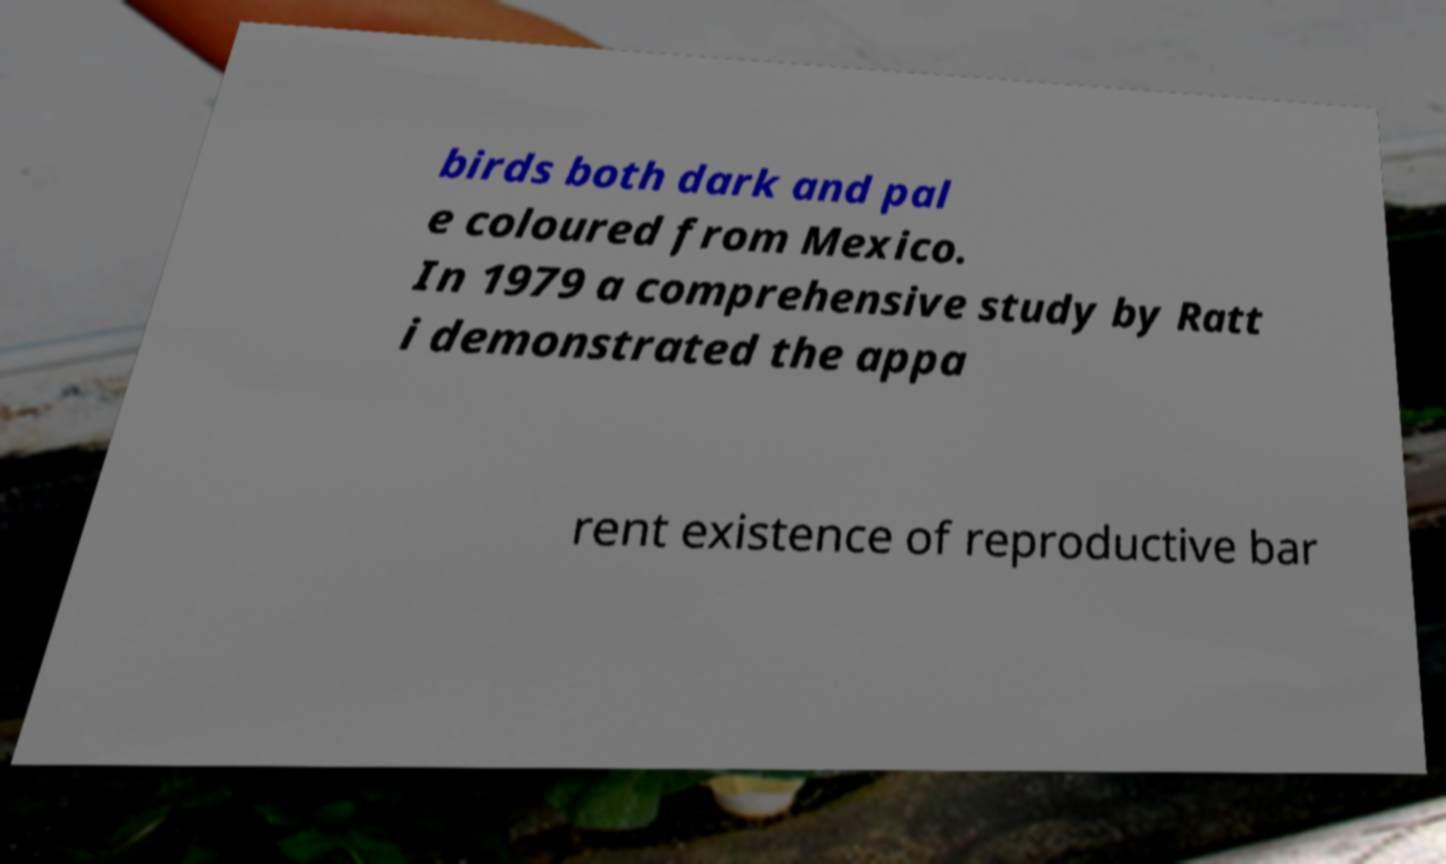There's text embedded in this image that I need extracted. Can you transcribe it verbatim? birds both dark and pal e coloured from Mexico. In 1979 a comprehensive study by Ratt i demonstrated the appa rent existence of reproductive bar 